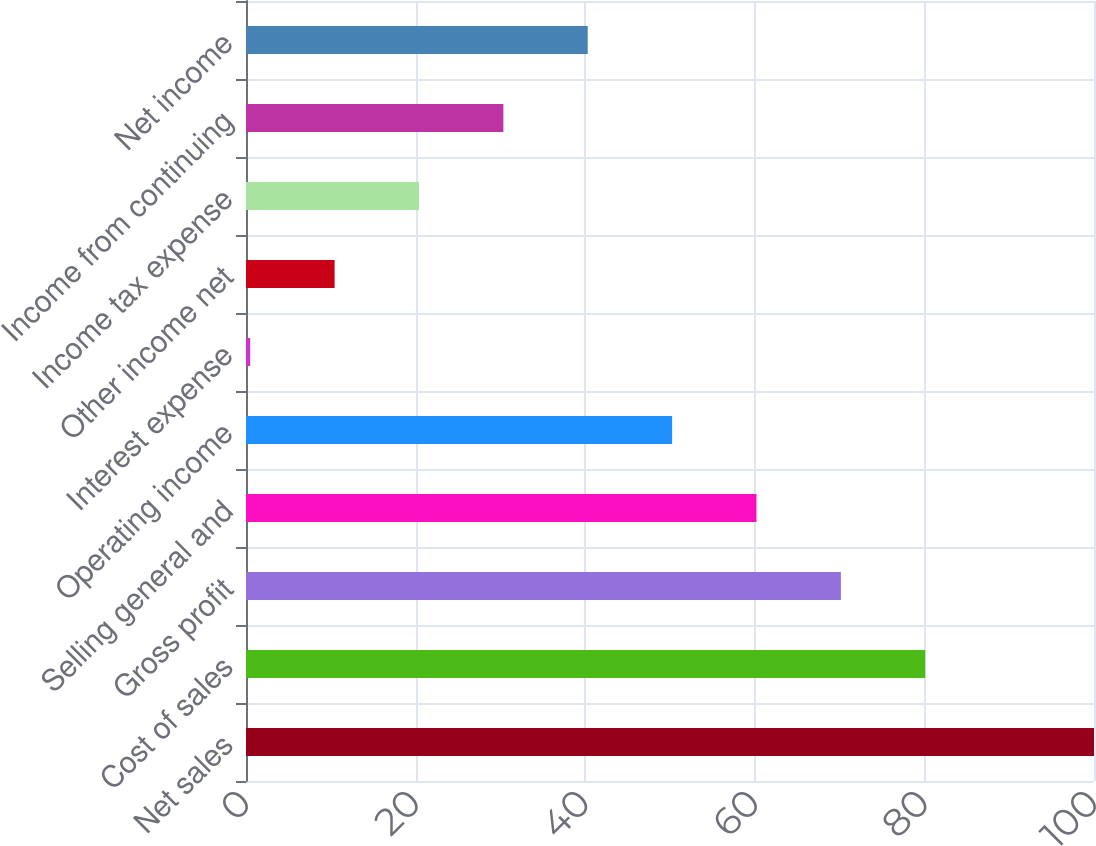<chart> <loc_0><loc_0><loc_500><loc_500><bar_chart><fcel>Net sales<fcel>Cost of sales<fcel>Gross profit<fcel>Selling general and<fcel>Operating income<fcel>Interest expense<fcel>Other income net<fcel>Income tax expense<fcel>Income from continuing<fcel>Net income<nl><fcel>100<fcel>80.1<fcel>70.15<fcel>60.2<fcel>50.25<fcel>0.5<fcel>10.45<fcel>20.4<fcel>30.35<fcel>40.3<nl></chart> 